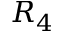Convert formula to latex. <formula><loc_0><loc_0><loc_500><loc_500>R _ { 4 }</formula> 